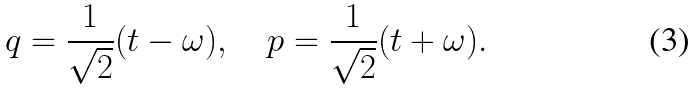Convert formula to latex. <formula><loc_0><loc_0><loc_500><loc_500>q = \frac { 1 } { \sqrt { 2 } } ( t - \omega ) , \quad p = \frac { 1 } { \sqrt { 2 } } ( t + \omega ) .</formula> 